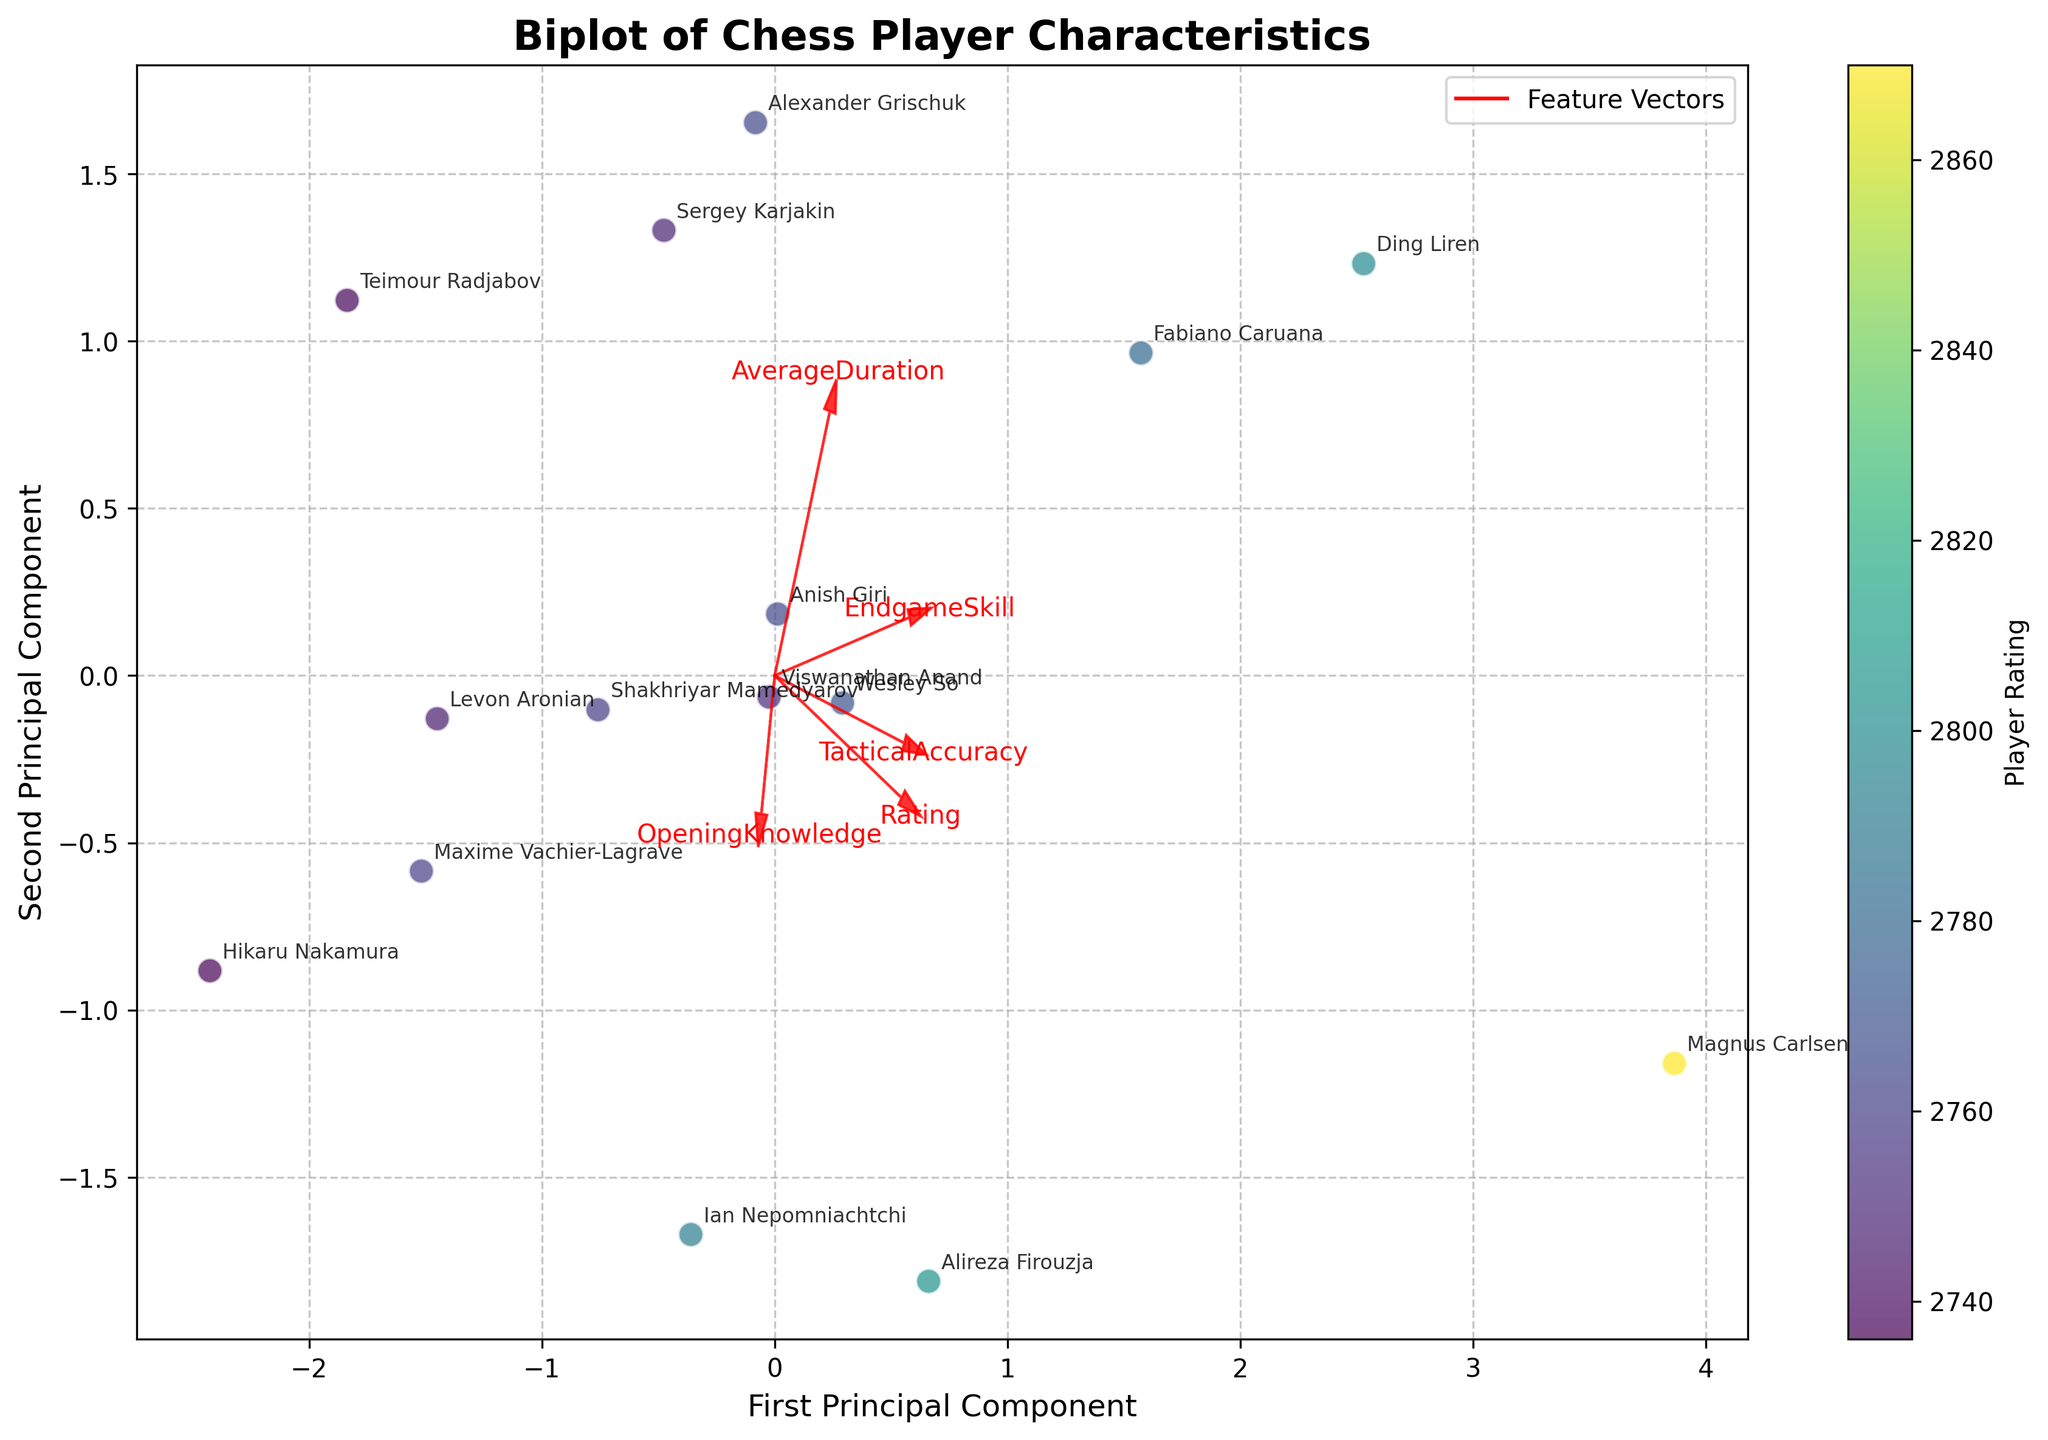what is the title of the figure? The title is typically displayed at the top of the figure. In this case, it is written in a larger font and bold style. It reads: "Biplot of Chess Player Characteristics."
Answer: Biplot of Chess Player Characteristics how many principal components are plotted on the x-axis? The x-axis label provides information on the principal components, and it reads, "First Principal Component." This indicates that the x-axis is plotting the first principal component.
Answer: One what does the color of each data point represent? The color bar adjacent to the plot indicates that the color of each data point represents the "Player Rating." Specifically, colors range from lower to higher as indicated by the color gradient from the viridis color map.
Answer: Player Rating who has the highest rating among the players displayed on the biplot? By examining the color-coded data points and analyzing the player names associated with the darkest shade representing the highest rating, Magnus Carlsen appears at the spot corresponding to the highest rating.
Answer: Magnus Carlsen which player is most associated with higher Principal Component 2 values based on the position in the plot? Ian Nepomniachtchi is located at the highest value along the y-axis (Principal Component 2). This can be deduced by observing the scatter plot annotations and finding the highest vertical point.
Answer: Ian Nepomniachtchi how many players have a rating represented by the lightest shade in the color map? The lighter shades in the color bar near the biplot represent lower ratings. We observe that Teimour Radjabov and Hikaru Nakamura are plotted with the lightest colors, making it a total of two players.
Answer: Two which feature has the most significant positive impact on the first principal component? By examining the feature vectors (arrows) pointing from (0,0), the feature "Rating" extends furthest along the x-axis (First Principal Component), indicating the strongest influence.
Answer: Rating looking at the feature vectors, which two features are most closely aligned? Observing the red arrows representing feature vectors, "OpeningKnowledge" and "EndgameSkill" are nearly in the same direction, suggesting a strong correlation.
Answer: OpeningKnowledge and EndgameSkill does the plot suggest a correlation between average game duration and Principal Component 1? The vector for "AverageDuration" points in more of an orthogonal direction to Principal Component 1, indicating a weaker correlation compared to features like 'Rating' and 'TacticalAccuracy.'
Answer: Weak correlation which player lies closest to the origin of the plot? By examining the positions of the annotated players, Wesley So is plotted nearest to the origin (0,0), based on his coordinates in the biplot.
Answer: Wesley So 